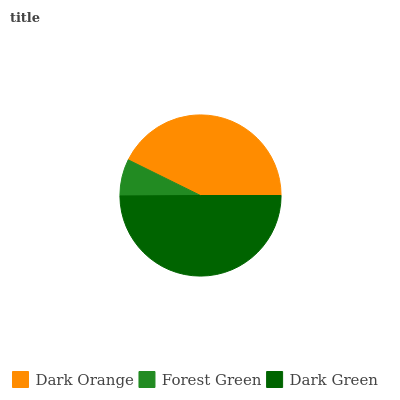Is Forest Green the minimum?
Answer yes or no. Yes. Is Dark Green the maximum?
Answer yes or no. Yes. Is Dark Green the minimum?
Answer yes or no. No. Is Forest Green the maximum?
Answer yes or no. No. Is Dark Green greater than Forest Green?
Answer yes or no. Yes. Is Forest Green less than Dark Green?
Answer yes or no. Yes. Is Forest Green greater than Dark Green?
Answer yes or no. No. Is Dark Green less than Forest Green?
Answer yes or no. No. Is Dark Orange the high median?
Answer yes or no. Yes. Is Dark Orange the low median?
Answer yes or no. Yes. Is Dark Green the high median?
Answer yes or no. No. Is Forest Green the low median?
Answer yes or no. No. 